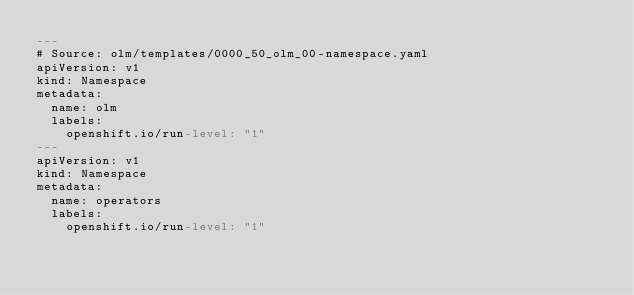<code> <loc_0><loc_0><loc_500><loc_500><_YAML_>---
# Source: olm/templates/0000_50_olm_00-namespace.yaml
apiVersion: v1
kind: Namespace
metadata:
  name: olm
  labels:
    openshift.io/run-level: "1"
---
apiVersion: v1
kind: Namespace
metadata:
  name: operators
  labels:
    openshift.io/run-level: "1"
</code> 